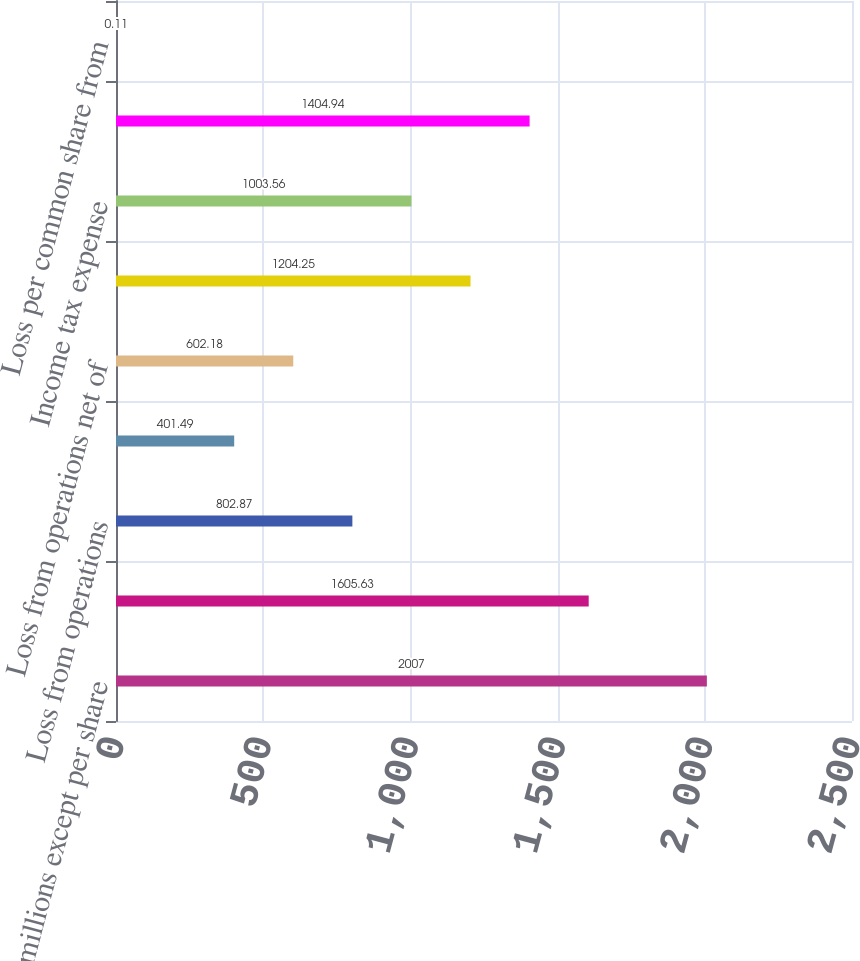<chart> <loc_0><loc_0><loc_500><loc_500><bar_chart><fcel>In millions except per share<fcel>Revenues<fcel>Loss from operations<fcel>Income tax benefit<fcel>Loss from operations net of<fcel>Loss on sales and impairments<fcel>Income tax expense<fcel>Loss from discontinued<fcel>Loss per common share from<nl><fcel>2007<fcel>1605.63<fcel>802.87<fcel>401.49<fcel>602.18<fcel>1204.25<fcel>1003.56<fcel>1404.94<fcel>0.11<nl></chart> 